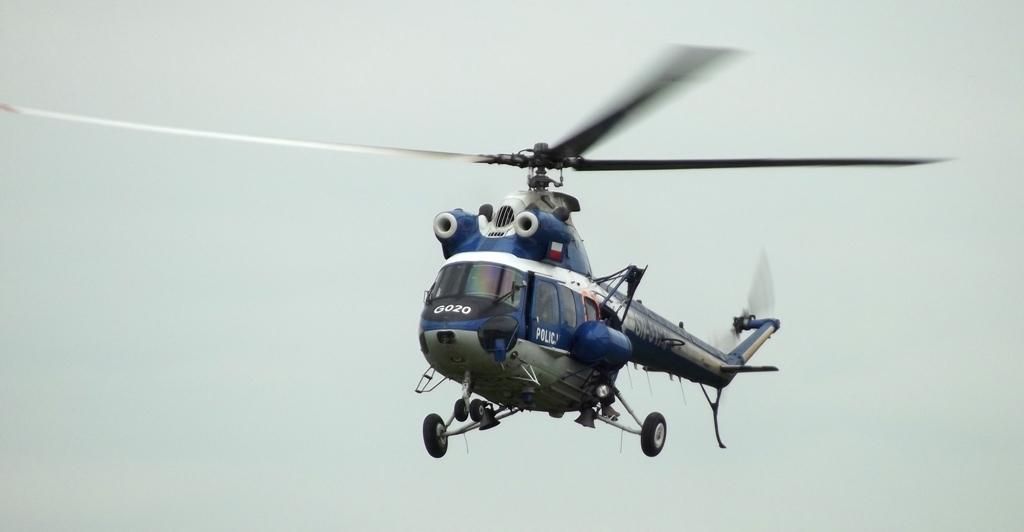What is the main subject of the image? The main subject of the image is a helicopter. Where is the helicopter located in the image? The helicopter is in the sky. What type of liquid is being poured by the bear in the image? There is no bear or liquid present in the image; it features a helicopter in the sky. 